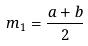<formula> <loc_0><loc_0><loc_500><loc_500>m _ { 1 } = \frac { a + b } { 2 }</formula> 